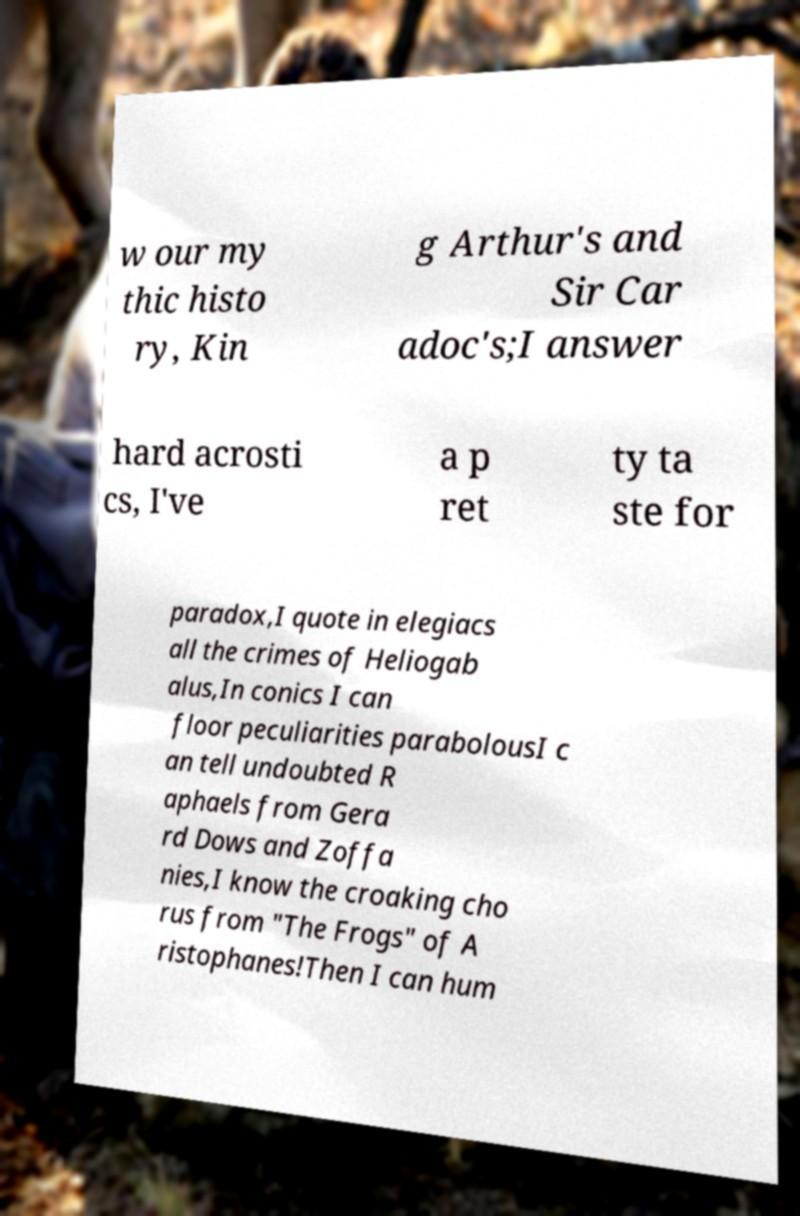Please identify and transcribe the text found in this image. w our my thic histo ry, Kin g Arthur's and Sir Car adoc's;I answer hard acrosti cs, I've a p ret ty ta ste for paradox,I quote in elegiacs all the crimes of Heliogab alus,In conics I can floor peculiarities parabolousI c an tell undoubted R aphaels from Gera rd Dows and Zoffa nies,I know the croaking cho rus from "The Frogs" of A ristophanes!Then I can hum 